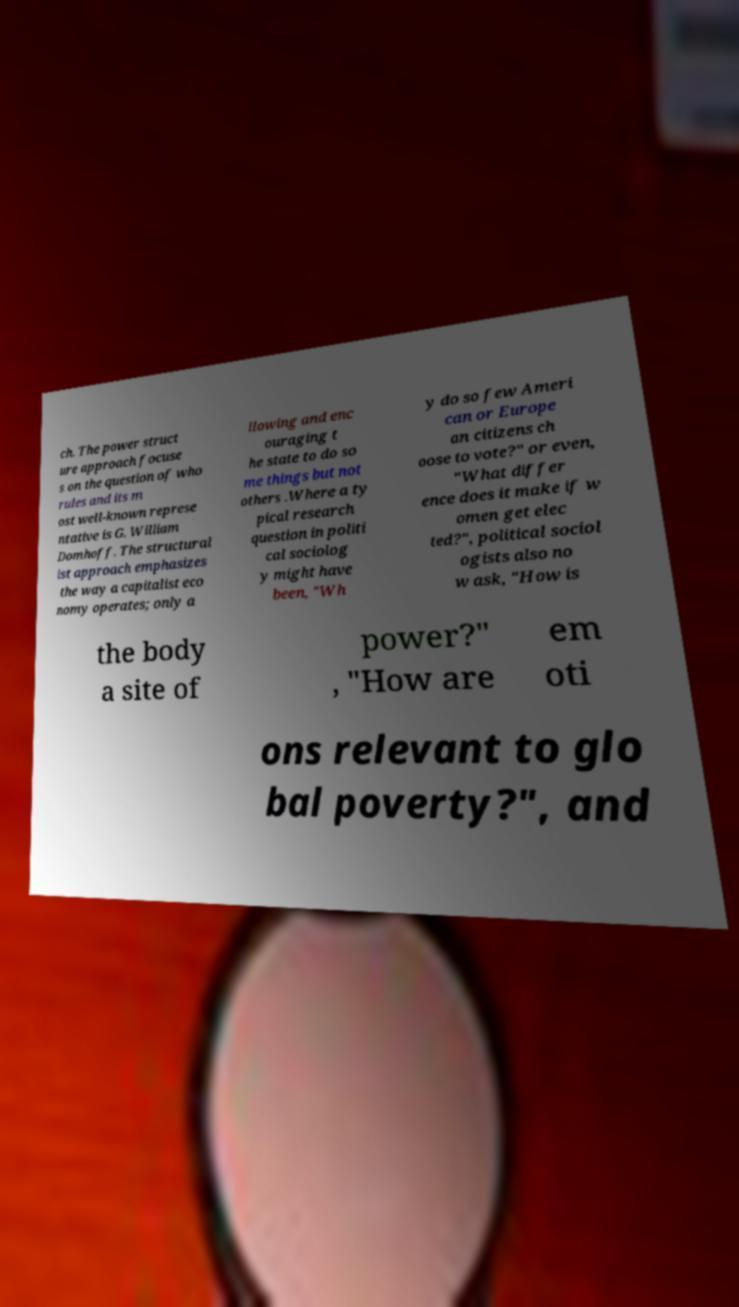Could you assist in decoding the text presented in this image and type it out clearly? ch. The power struct ure approach focuse s on the question of who rules and its m ost well-known represe ntative is G. William Domhoff. The structural ist approach emphasizes the way a capitalist eco nomy operates; only a llowing and enc ouraging t he state to do so me things but not others .Where a ty pical research question in politi cal sociolog y might have been, "Wh y do so few Ameri can or Europe an citizens ch oose to vote?" or even, "What differ ence does it make if w omen get elec ted?", political sociol ogists also no w ask, "How is the body a site of power?" , "How are em oti ons relevant to glo bal poverty?", and 